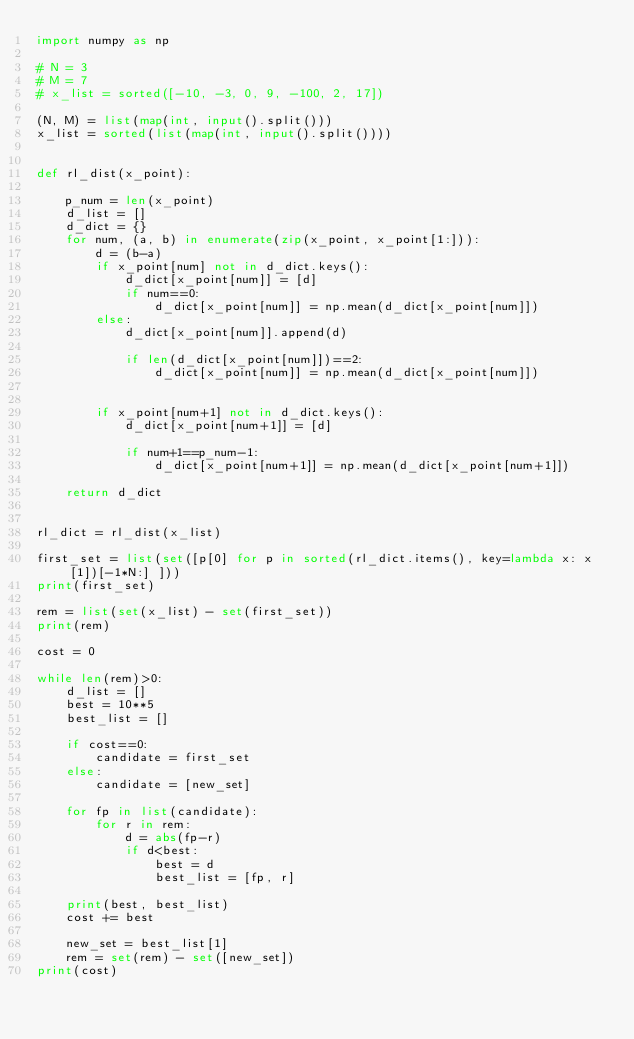Convert code to text. <code><loc_0><loc_0><loc_500><loc_500><_Python_>import numpy as np

# N = 3
# M = 7
# x_list = sorted([-10, -3, 0, 9, -100, 2, 17])

(N, M) = list(map(int, input().split()))
x_list = sorted(list(map(int, input().split())))


def rl_dist(x_point):

    p_num = len(x_point)
    d_list = []
    d_dict = {}
    for num, (a, b) in enumerate(zip(x_point, x_point[1:])):
        d = (b-a)
        if x_point[num] not in d_dict.keys():
            d_dict[x_point[num]] = [d]
            if num==0:
                d_dict[x_point[num]] = np.mean(d_dict[x_point[num]])
        else:
            d_dict[x_point[num]].append(d)
            
            if len(d_dict[x_point[num]])==2:
                d_dict[x_point[num]] = np.mean(d_dict[x_point[num]])
                
            
        if x_point[num+1] not in d_dict.keys():
            d_dict[x_point[num+1]] = [d]
            
            if num+1==p_num-1:
                d_dict[x_point[num+1]] = np.mean(d_dict[x_point[num+1]])
                
    return d_dict
            
    
rl_dict = rl_dist(x_list)
        
first_set = list(set([p[0] for p in sorted(rl_dict.items(), key=lambda x: x[1])[-1*N:] ]))
print(first_set)

rem = list(set(x_list) - set(first_set))
print(rem)

cost = 0

while len(rem)>0:
    d_list = []
    best = 10**5
    best_list = []
    
    if cost==0:
        candidate = first_set
    else:
        candidate = [new_set]
    
    for fp in list(candidate):
        for r in rem:
            d = abs(fp-r)
            if d<best:
                best = d
                best_list = [fp, r]
    
    print(best, best_list)
    cost += best
    
    new_set = best_list[1]
    rem = set(rem) - set([new_set])
print(cost)</code> 